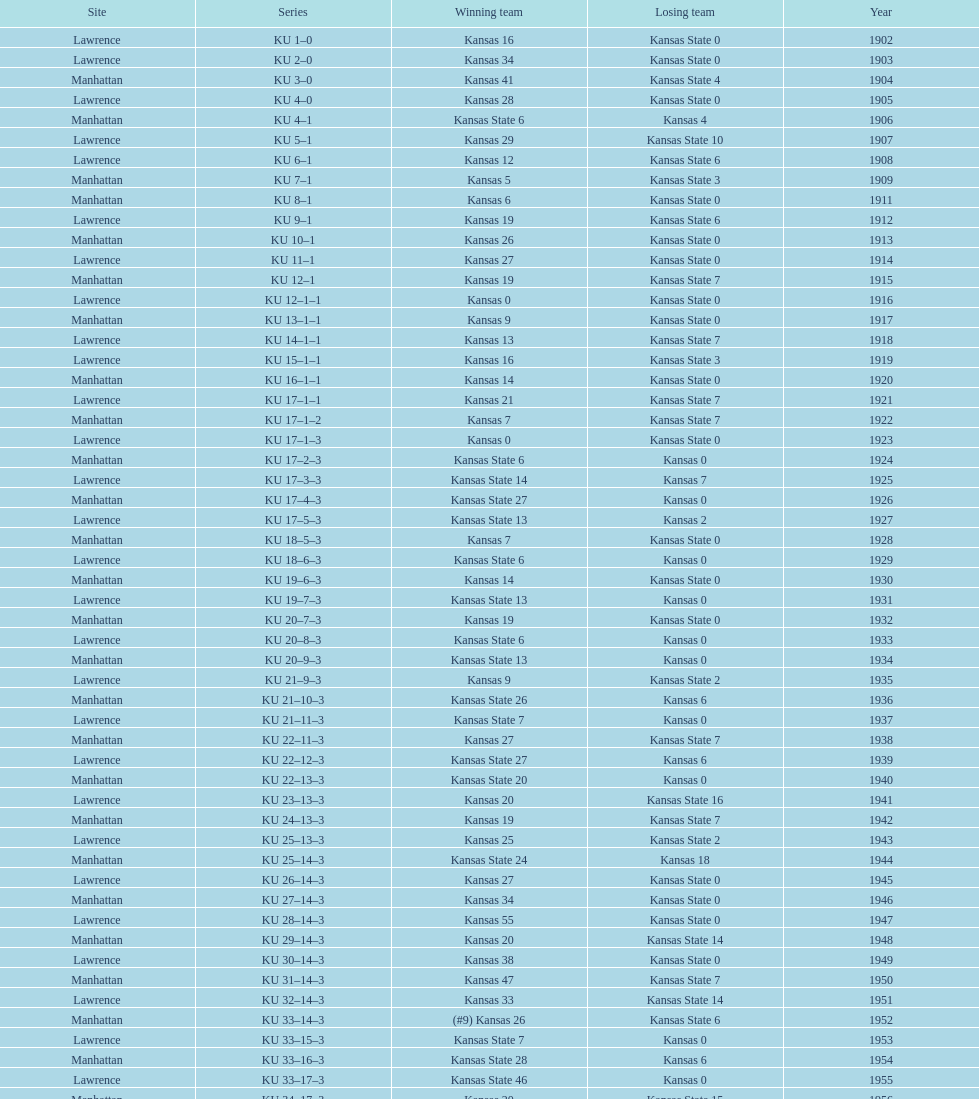How many times did kansas and kansas state play in lawrence from 1902-1968? 34. 